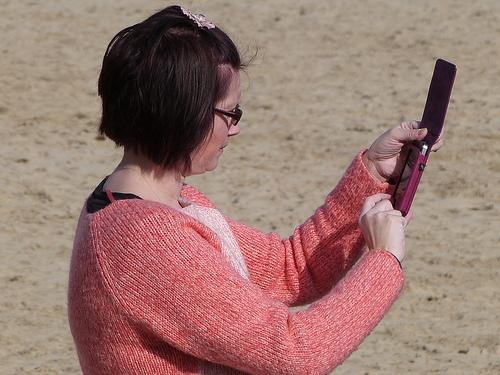Describe the surface on which the woman is standing in the image. The woman is standing on sandy ground. Briefly explain what the woman is doing with her hands in the image. The woman is holding a cell phone with one hand and using her other hand to push buttons on it. Provide a description of the clothing under the woman's sweater. She is wearing a black shirt and a pink shirt under the sweater. What color is the woman's sweater and what is she doing? The woman is wearing a pink sweater and holding a cell phone. How is the woman's hair secured in the image? The woman's hair is held back by a barrette. Comment on the woman's appearance, including her hair color and style. The woman has brunette or dark brown hair, cut in a bob style, with some hair sticking up. What type of accessory can be seen on the woman's head? There is a flower decoration and a pink bow in the woman's hair. What sort of device is in the woman's hand, and what is its color? The woman is holding a cell phone with a plum, or pinkish-purple, casing. Identify the color and type of eyewear the woman has on her face. The woman is wearing black, plastic glasses. Discuss the sentiment expressed by the image and the activity being represented. The image depicts a casual and relaxed moment, with the woman standing on sandy ground and engaging with her cell phone. What type of hair accessory is holding back the woman's hair? A barrette. Identify if there are any visible barriers or rigid boundaries separating different parts of the image. No visible barriers or rigid boundaries. What are the colors of the woman's hair and glasses in the image? Her hair is brown (brunette), and the glasses are black. What color is the woman's sweater in the picture? Pink What color is the sand surrounding the woman in the image? The sand is brown. Determine whether any of these objects are in the image: a) pink bow b) dog c) car d) pair of glasses a) pink bow, d) pair of glasses Describe the scene in the image with information about the woman's hair, clothing, and accessories. The woman is brunette with her hair cut in a bob, wearing glasses, a pink sweater, and a black shirt under the sweater. She also has a pink bow and flower decoration in her hair and a thin necklace on her neck. Is the woman wearing any jewelry, and if so, what kind? Yes, she is wearing a thin necklace. Is there anything attached to the woman's thumb in the picture? Yes, there is a fingernail attached to her thumb. Examine the details in the image and describe what the woman is doing with her hands. The woman's left hand is on top of the game system, and her right hand is on the bottom of the system. She is also holding a cell phone. Describe the woman's appearance in the picture. Include details about her clothing, hairstyle, and accessories. The woman has brown hair cut in a bob, wears glasses, a pink sweater, a black shirt, and a thin necklace. She has a pink bow and a flower decoration in her hair. What can be observed on the ground behind the woman? There is sandy ground in the background. In the picture, connect the woman's attire and related objects: a) pink sweater b) glasses c) cellphone d) pink shirt under the sweater e) light-colored panel a) pink sweater: d) pink shirt under the sweater, e) light-colored panel; b) glasses; c) cellphone Select the main tasks the woman is performing in the photo: a) texting on a cell phone b) cooking c) reading a book d) playing a game system a) texting on a cell phone, d) playing a game system What additional object is on top of the cell phone? A purple case. Create a cohesive narrative that includes the woman, her actions, and the objects in the image. A woman with a bob haircut is standing on sandy ground, wearing a pink sweater, a black shirt, and glasses. In her hands, she holds a cell phone with a purple case and operates a pink game system. Her hair is adorned with a pink bow and a flower decoration, and she wears a thin necklace. The woman is holding an object in her hand. What is the color of the case on the object? The case is plum (purple) colored. 